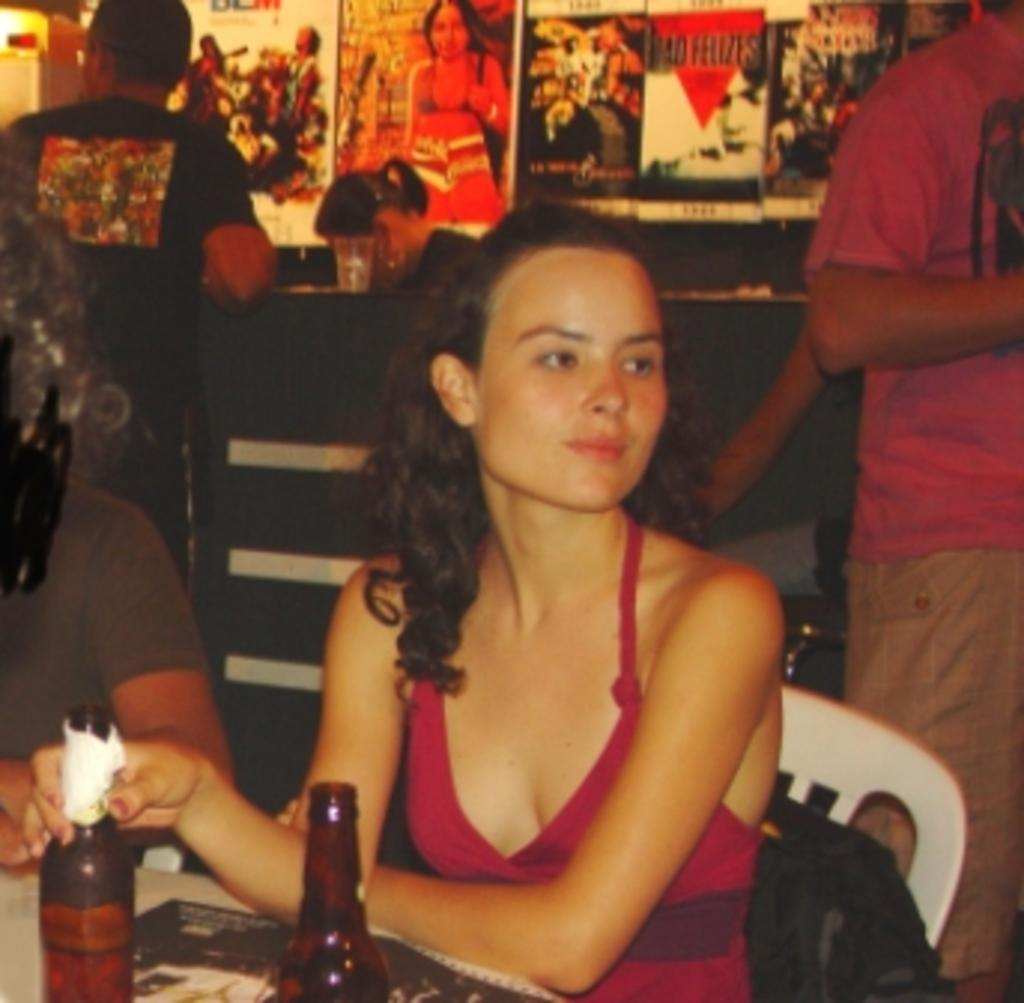What is the woman in the image doing? The woman is sitting on a chair in the image. What else can be seen in the image besides the woman? There are bottles visible in the image. Can you describe the other people present in the image? The other people present in the image have their faces not visible. What type of event or party is happening in the image? There is no indication of an event or party happening in the image. The image only shows a woman sitting on a chair, bottles, and other people with their faces not visible. 